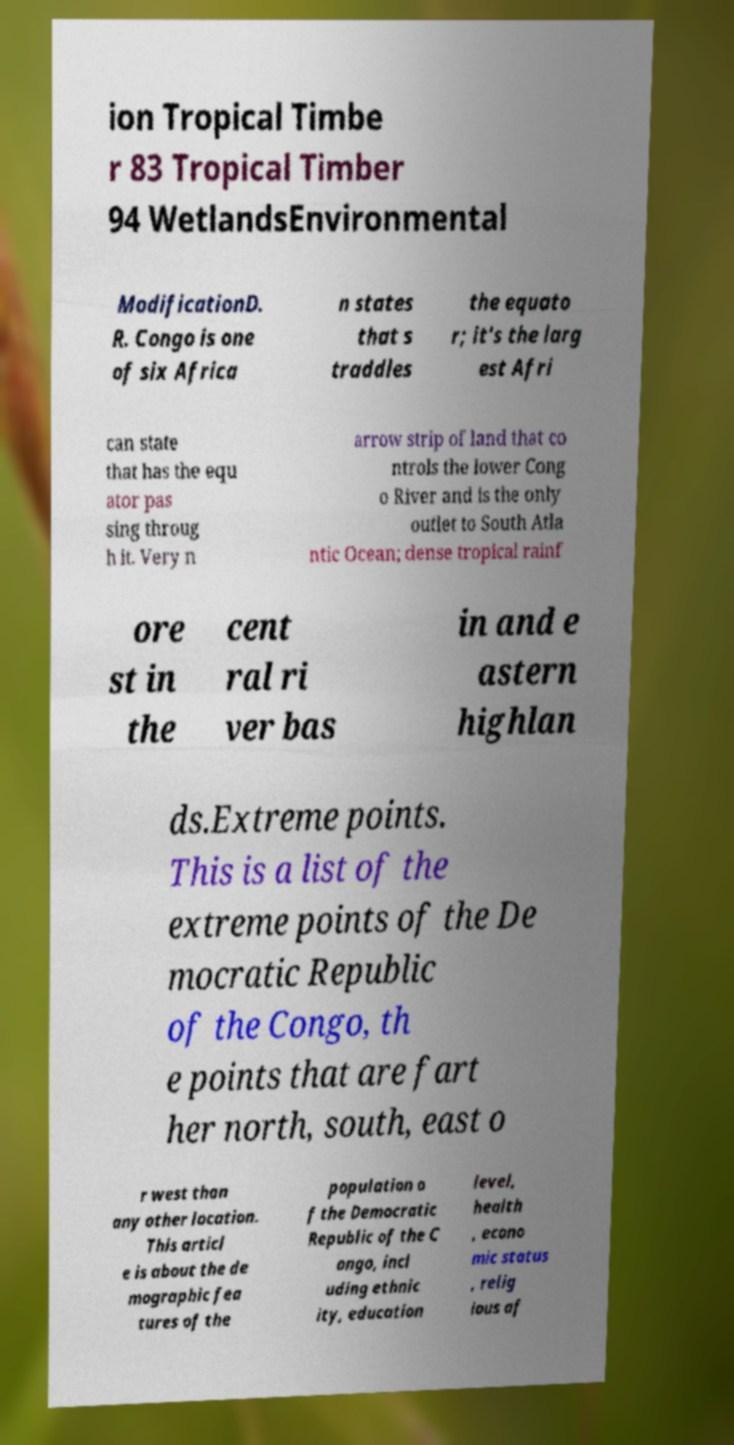I need the written content from this picture converted into text. Can you do that? ion Tropical Timbe r 83 Tropical Timber 94 WetlandsEnvironmental ModificationD. R. Congo is one of six Africa n states that s traddles the equato r; it's the larg est Afri can state that has the equ ator pas sing throug h it. Very n arrow strip of land that co ntrols the lower Cong o River and is the only outlet to South Atla ntic Ocean; dense tropical rainf ore st in the cent ral ri ver bas in and e astern highlan ds.Extreme points. This is a list of the extreme points of the De mocratic Republic of the Congo, th e points that are fart her north, south, east o r west than any other location. This articl e is about the de mographic fea tures of the population o f the Democratic Republic of the C ongo, incl uding ethnic ity, education level, health , econo mic status , relig ious af 